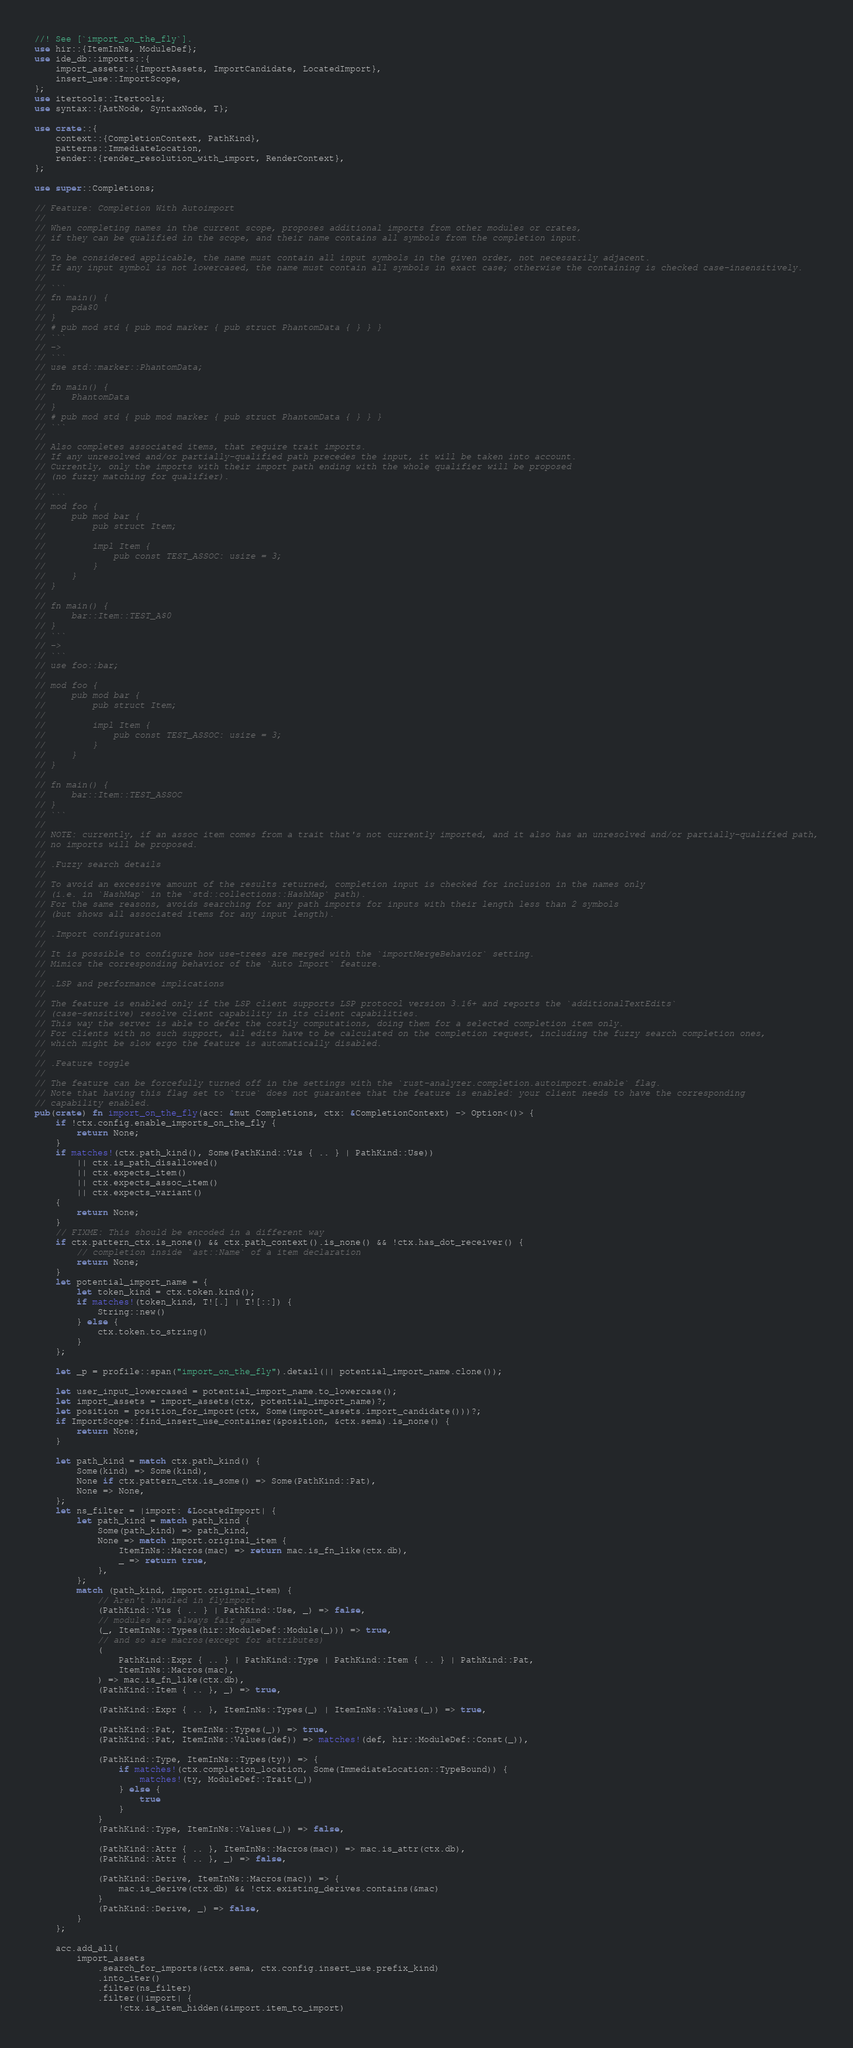<code> <loc_0><loc_0><loc_500><loc_500><_Rust_>//! See [`import_on_the_fly`].
use hir::{ItemInNs, ModuleDef};
use ide_db::imports::{
    import_assets::{ImportAssets, ImportCandidate, LocatedImport},
    insert_use::ImportScope,
};
use itertools::Itertools;
use syntax::{AstNode, SyntaxNode, T};

use crate::{
    context::{CompletionContext, PathKind},
    patterns::ImmediateLocation,
    render::{render_resolution_with_import, RenderContext},
};

use super::Completions;

// Feature: Completion With Autoimport
//
// When completing names in the current scope, proposes additional imports from other modules or crates,
// if they can be qualified in the scope, and their name contains all symbols from the completion input.
//
// To be considered applicable, the name must contain all input symbols in the given order, not necessarily adjacent.
// If any input symbol is not lowercased, the name must contain all symbols in exact case; otherwise the containing is checked case-insensitively.
//
// ```
// fn main() {
//     pda$0
// }
// # pub mod std { pub mod marker { pub struct PhantomData { } } }
// ```
// ->
// ```
// use std::marker::PhantomData;
//
// fn main() {
//     PhantomData
// }
// # pub mod std { pub mod marker { pub struct PhantomData { } } }
// ```
//
// Also completes associated items, that require trait imports.
// If any unresolved and/or partially-qualified path precedes the input, it will be taken into account.
// Currently, only the imports with their import path ending with the whole qualifier will be proposed
// (no fuzzy matching for qualifier).
//
// ```
// mod foo {
//     pub mod bar {
//         pub struct Item;
//
//         impl Item {
//             pub const TEST_ASSOC: usize = 3;
//         }
//     }
// }
//
// fn main() {
//     bar::Item::TEST_A$0
// }
// ```
// ->
// ```
// use foo::bar;
//
// mod foo {
//     pub mod bar {
//         pub struct Item;
//
//         impl Item {
//             pub const TEST_ASSOC: usize = 3;
//         }
//     }
// }
//
// fn main() {
//     bar::Item::TEST_ASSOC
// }
// ```
//
// NOTE: currently, if an assoc item comes from a trait that's not currently imported, and it also has an unresolved and/or partially-qualified path,
// no imports will be proposed.
//
// .Fuzzy search details
//
// To avoid an excessive amount of the results returned, completion input is checked for inclusion in the names only
// (i.e. in `HashMap` in the `std::collections::HashMap` path).
// For the same reasons, avoids searching for any path imports for inputs with their length less than 2 symbols
// (but shows all associated items for any input length).
//
// .Import configuration
//
// It is possible to configure how use-trees are merged with the `importMergeBehavior` setting.
// Mimics the corresponding behavior of the `Auto Import` feature.
//
// .LSP and performance implications
//
// The feature is enabled only if the LSP client supports LSP protocol version 3.16+ and reports the `additionalTextEdits`
// (case-sensitive) resolve client capability in its client capabilities.
// This way the server is able to defer the costly computations, doing them for a selected completion item only.
// For clients with no such support, all edits have to be calculated on the completion request, including the fuzzy search completion ones,
// which might be slow ergo the feature is automatically disabled.
//
// .Feature toggle
//
// The feature can be forcefully turned off in the settings with the `rust-analyzer.completion.autoimport.enable` flag.
// Note that having this flag set to `true` does not guarantee that the feature is enabled: your client needs to have the corresponding
// capability enabled.
pub(crate) fn import_on_the_fly(acc: &mut Completions, ctx: &CompletionContext) -> Option<()> {
    if !ctx.config.enable_imports_on_the_fly {
        return None;
    }
    if matches!(ctx.path_kind(), Some(PathKind::Vis { .. } | PathKind::Use))
        || ctx.is_path_disallowed()
        || ctx.expects_item()
        || ctx.expects_assoc_item()
        || ctx.expects_variant()
    {
        return None;
    }
    // FIXME: This should be encoded in a different way
    if ctx.pattern_ctx.is_none() && ctx.path_context().is_none() && !ctx.has_dot_receiver() {
        // completion inside `ast::Name` of a item declaration
        return None;
    }
    let potential_import_name = {
        let token_kind = ctx.token.kind();
        if matches!(token_kind, T![.] | T![::]) {
            String::new()
        } else {
            ctx.token.to_string()
        }
    };

    let _p = profile::span("import_on_the_fly").detail(|| potential_import_name.clone());

    let user_input_lowercased = potential_import_name.to_lowercase();
    let import_assets = import_assets(ctx, potential_import_name)?;
    let position = position_for_import(ctx, Some(import_assets.import_candidate()))?;
    if ImportScope::find_insert_use_container(&position, &ctx.sema).is_none() {
        return None;
    }

    let path_kind = match ctx.path_kind() {
        Some(kind) => Some(kind),
        None if ctx.pattern_ctx.is_some() => Some(PathKind::Pat),
        None => None,
    };
    let ns_filter = |import: &LocatedImport| {
        let path_kind = match path_kind {
            Some(path_kind) => path_kind,
            None => match import.original_item {
                ItemInNs::Macros(mac) => return mac.is_fn_like(ctx.db),
                _ => return true,
            },
        };
        match (path_kind, import.original_item) {
            // Aren't handled in flyimport
            (PathKind::Vis { .. } | PathKind::Use, _) => false,
            // modules are always fair game
            (_, ItemInNs::Types(hir::ModuleDef::Module(_))) => true,
            // and so are macros(except for attributes)
            (
                PathKind::Expr { .. } | PathKind::Type | PathKind::Item { .. } | PathKind::Pat,
                ItemInNs::Macros(mac),
            ) => mac.is_fn_like(ctx.db),
            (PathKind::Item { .. }, _) => true,

            (PathKind::Expr { .. }, ItemInNs::Types(_) | ItemInNs::Values(_)) => true,

            (PathKind::Pat, ItemInNs::Types(_)) => true,
            (PathKind::Pat, ItemInNs::Values(def)) => matches!(def, hir::ModuleDef::Const(_)),

            (PathKind::Type, ItemInNs::Types(ty)) => {
                if matches!(ctx.completion_location, Some(ImmediateLocation::TypeBound)) {
                    matches!(ty, ModuleDef::Trait(_))
                } else {
                    true
                }
            }
            (PathKind::Type, ItemInNs::Values(_)) => false,

            (PathKind::Attr { .. }, ItemInNs::Macros(mac)) => mac.is_attr(ctx.db),
            (PathKind::Attr { .. }, _) => false,

            (PathKind::Derive, ItemInNs::Macros(mac)) => {
                mac.is_derive(ctx.db) && !ctx.existing_derives.contains(&mac)
            }
            (PathKind::Derive, _) => false,
        }
    };

    acc.add_all(
        import_assets
            .search_for_imports(&ctx.sema, ctx.config.insert_use.prefix_kind)
            .into_iter()
            .filter(ns_filter)
            .filter(|import| {
                !ctx.is_item_hidden(&import.item_to_import)</code> 